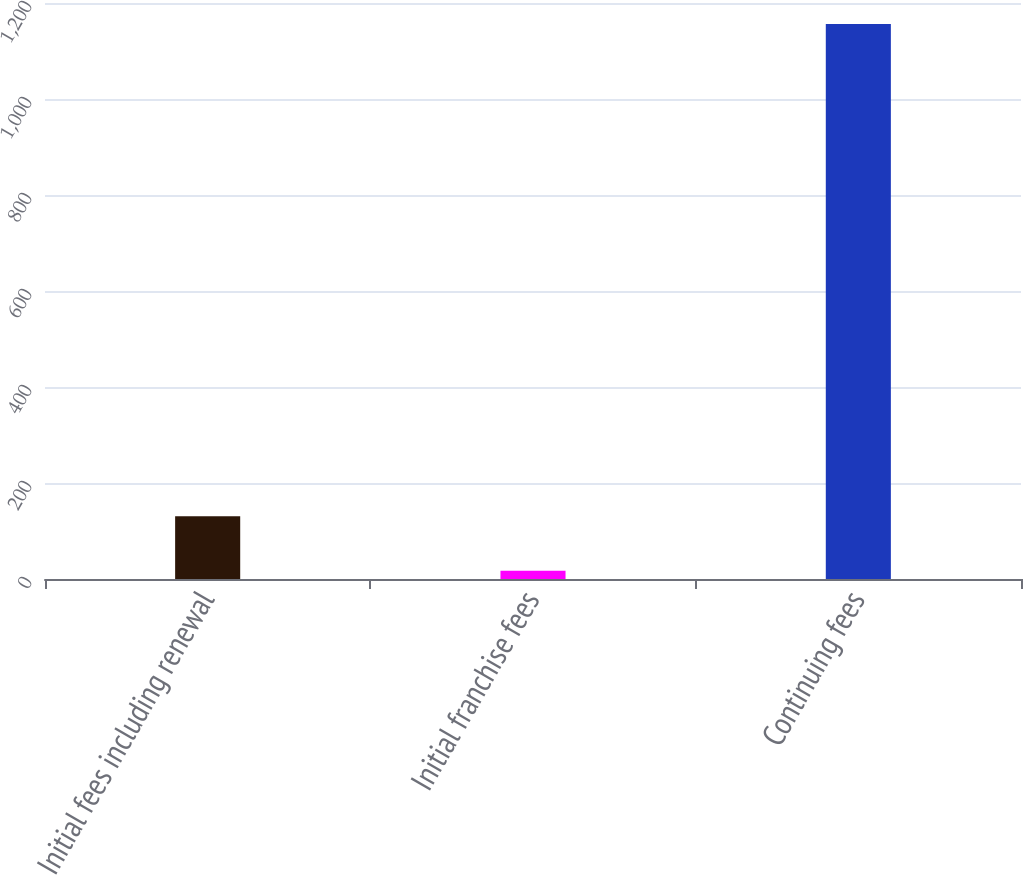Convert chart. <chart><loc_0><loc_0><loc_500><loc_500><bar_chart><fcel>Initial fees including renewal<fcel>Initial franchise fees<fcel>Continuing fees<nl><fcel>130.9<fcel>17<fcel>1156<nl></chart> 